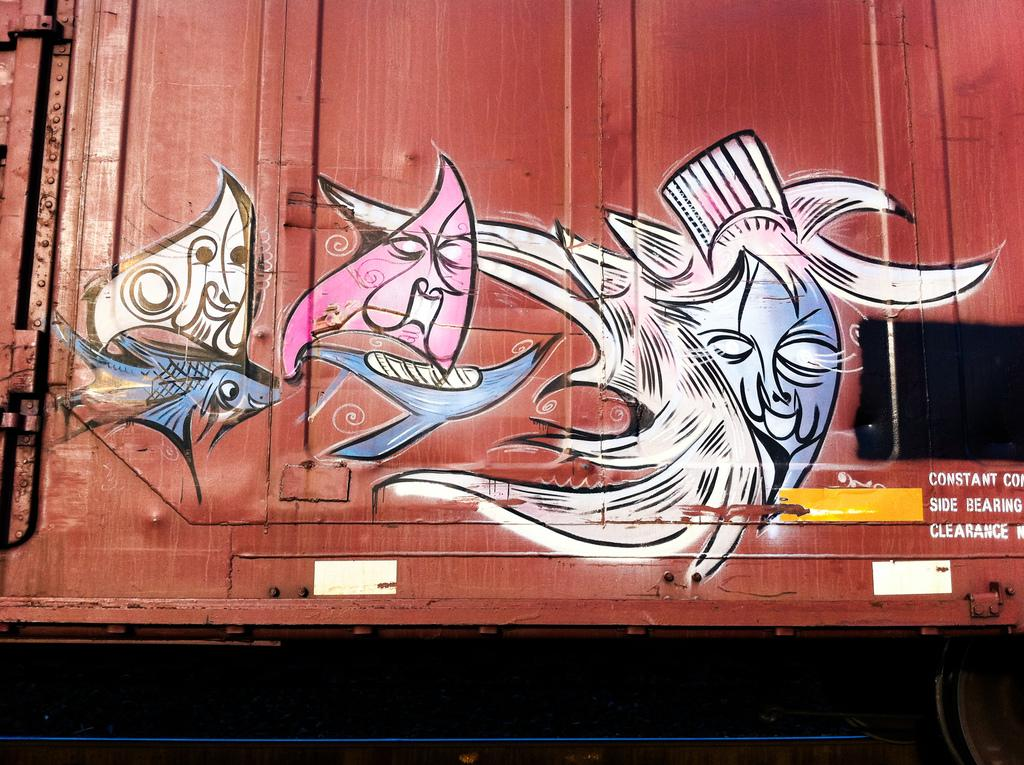What is depicted on the container in the image? There is graffiti on a container in the image. What type of curtain is hanging in front of the container in the image? There is no curtain present in the image; it only features a container with graffiti. How many bits are visible on the container in the image? There are no bits present in the image; it only features a container with graffiti. What type of pickle is shown inside the container in the image? There is no pickle present in the image; it only features a container with graffiti. 